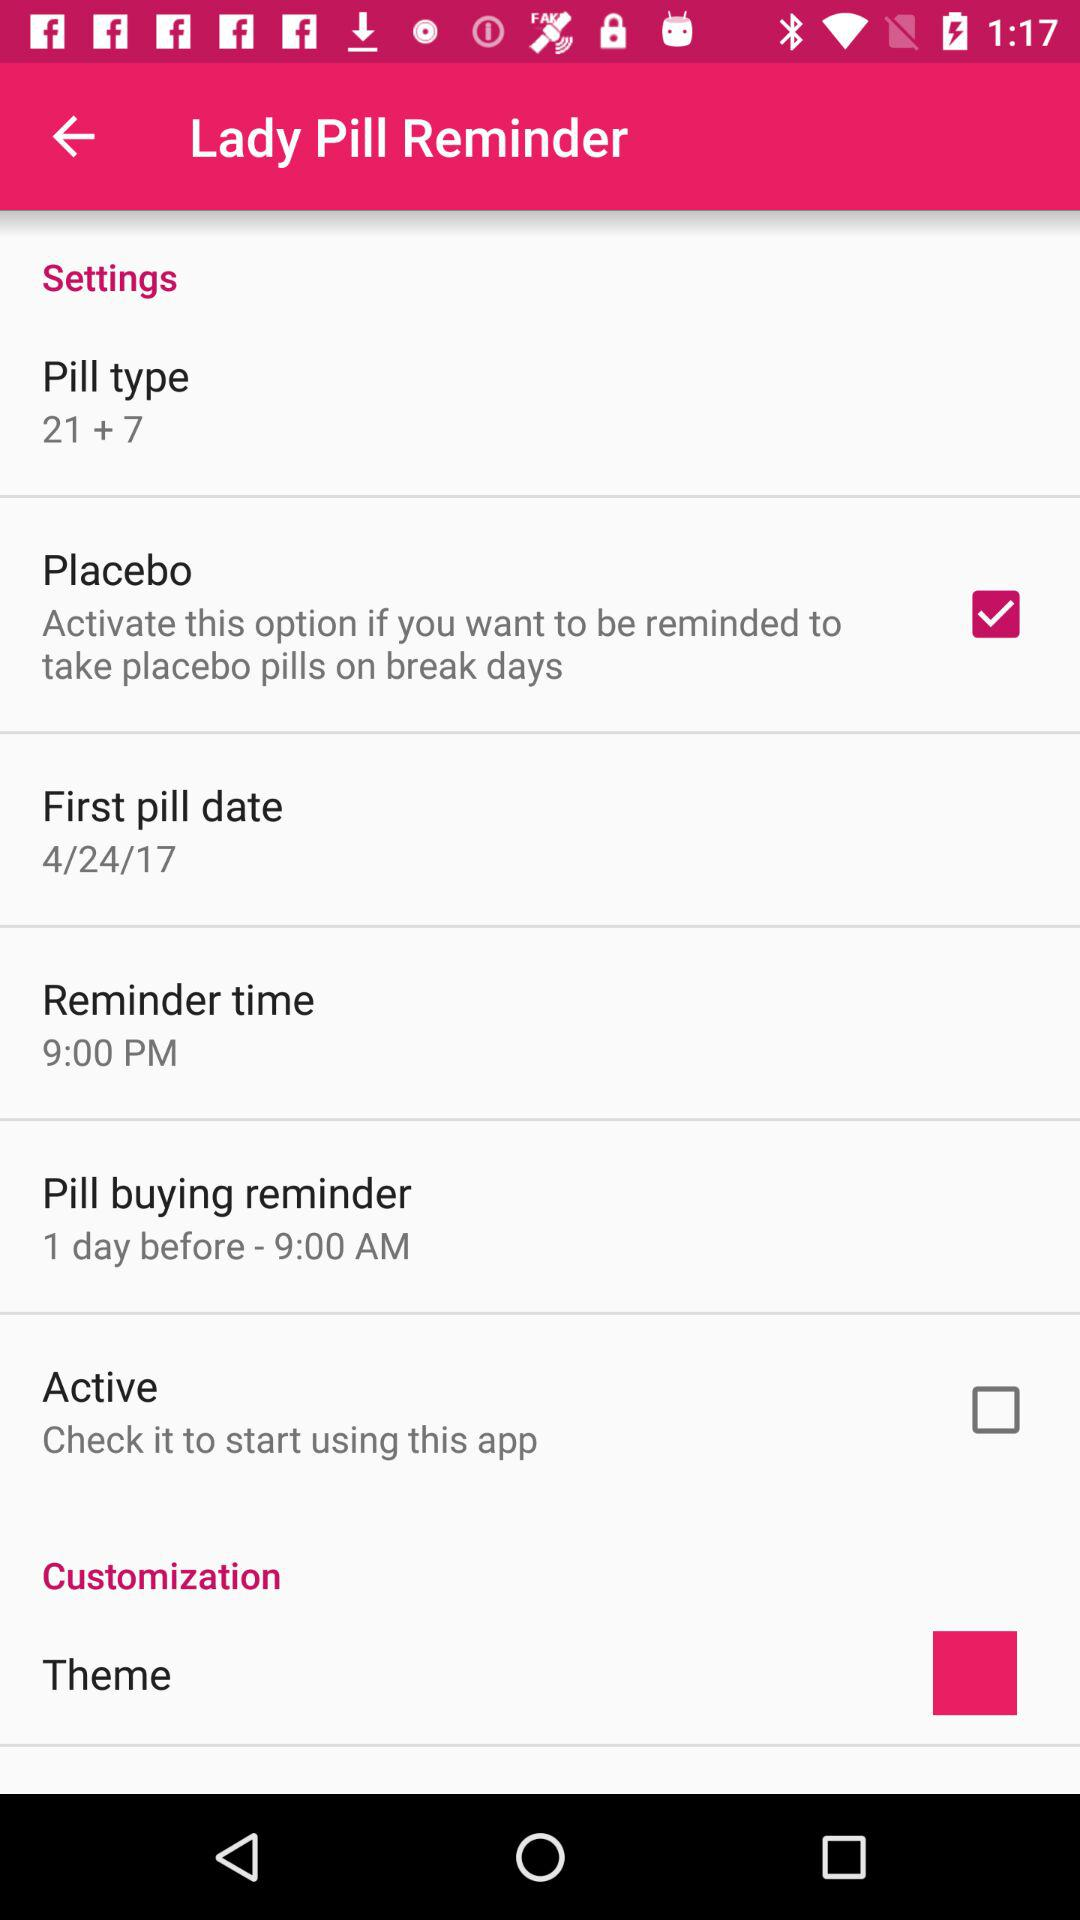What is the pill type? The pill type is "21 + 7". 